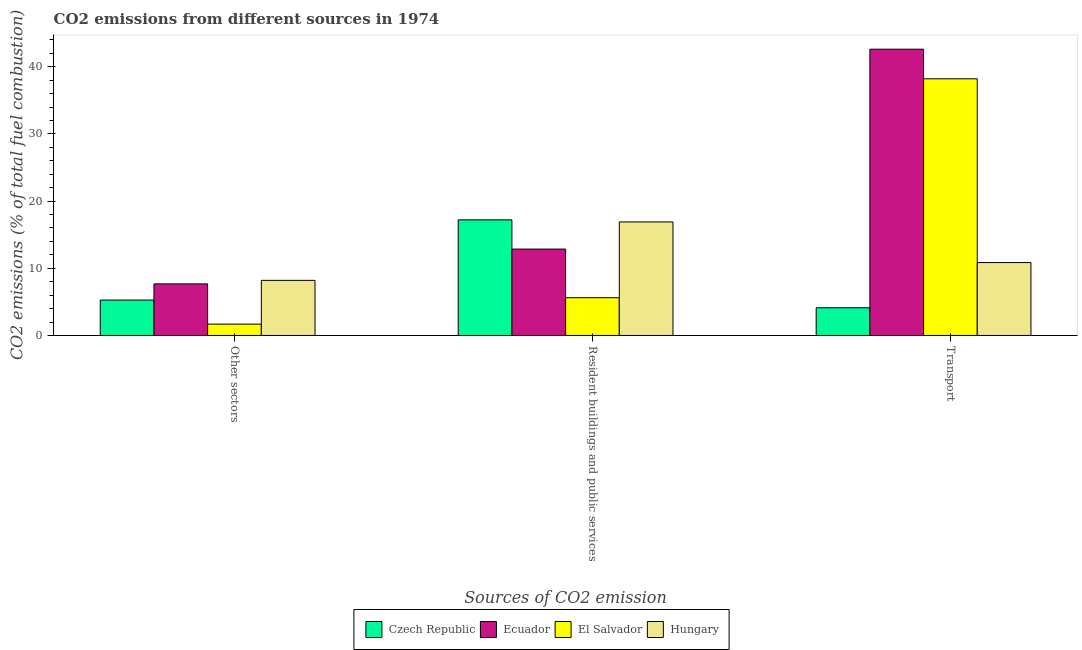Are the number of bars per tick equal to the number of legend labels?
Give a very brief answer. Yes. What is the label of the 2nd group of bars from the left?
Offer a very short reply. Resident buildings and public services. What is the percentage of co2 emissions from resident buildings and public services in Ecuador?
Provide a succinct answer. 12.86. Across all countries, what is the maximum percentage of co2 emissions from other sectors?
Offer a very short reply. 8.2. Across all countries, what is the minimum percentage of co2 emissions from other sectors?
Your response must be concise. 1.69. In which country was the percentage of co2 emissions from other sectors maximum?
Offer a very short reply. Hungary. In which country was the percentage of co2 emissions from transport minimum?
Ensure brevity in your answer.  Czech Republic. What is the total percentage of co2 emissions from other sectors in the graph?
Make the answer very short. 22.84. What is the difference between the percentage of co2 emissions from other sectors in Czech Republic and that in Ecuador?
Keep it short and to the point. -2.41. What is the difference between the percentage of co2 emissions from other sectors in Czech Republic and the percentage of co2 emissions from transport in El Salvador?
Make the answer very short. -32.93. What is the average percentage of co2 emissions from transport per country?
Offer a terse response. 23.95. What is the difference between the percentage of co2 emissions from resident buildings and public services and percentage of co2 emissions from transport in Hungary?
Your answer should be compact. 6.05. What is the ratio of the percentage of co2 emissions from resident buildings and public services in Czech Republic to that in Hungary?
Give a very brief answer. 1.02. Is the percentage of co2 emissions from transport in Ecuador less than that in Czech Republic?
Provide a succinct answer. No. Is the difference between the percentage of co2 emissions from resident buildings and public services in El Salvador and Hungary greater than the difference between the percentage of co2 emissions from transport in El Salvador and Hungary?
Offer a very short reply. No. What is the difference between the highest and the second highest percentage of co2 emissions from resident buildings and public services?
Provide a succinct answer. 0.31. What is the difference between the highest and the lowest percentage of co2 emissions from resident buildings and public services?
Ensure brevity in your answer.  11.59. What does the 3rd bar from the left in Other sectors represents?
Provide a succinct answer. El Salvador. What does the 1st bar from the right in Transport represents?
Offer a very short reply. Hungary. How many bars are there?
Keep it short and to the point. 12. Are all the bars in the graph horizontal?
Keep it short and to the point. No. What is the difference between two consecutive major ticks on the Y-axis?
Give a very brief answer. 10. Are the values on the major ticks of Y-axis written in scientific E-notation?
Your answer should be very brief. No. Does the graph contain any zero values?
Keep it short and to the point. No. Does the graph contain grids?
Give a very brief answer. No. How many legend labels are there?
Ensure brevity in your answer.  4. What is the title of the graph?
Offer a terse response. CO2 emissions from different sources in 1974. Does "Ireland" appear as one of the legend labels in the graph?
Make the answer very short. No. What is the label or title of the X-axis?
Give a very brief answer. Sources of CO2 emission. What is the label or title of the Y-axis?
Offer a very short reply. CO2 emissions (% of total fuel combustion). What is the CO2 emissions (% of total fuel combustion) in Czech Republic in Other sectors?
Ensure brevity in your answer.  5.27. What is the CO2 emissions (% of total fuel combustion) of Ecuador in Other sectors?
Make the answer very short. 7.68. What is the CO2 emissions (% of total fuel combustion) of El Salvador in Other sectors?
Your response must be concise. 1.69. What is the CO2 emissions (% of total fuel combustion) of Hungary in Other sectors?
Provide a succinct answer. 8.2. What is the CO2 emissions (% of total fuel combustion) in Czech Republic in Resident buildings and public services?
Offer a terse response. 17.21. What is the CO2 emissions (% of total fuel combustion) of Ecuador in Resident buildings and public services?
Your response must be concise. 12.86. What is the CO2 emissions (% of total fuel combustion) of El Salvador in Resident buildings and public services?
Offer a very short reply. 5.62. What is the CO2 emissions (% of total fuel combustion) in Hungary in Resident buildings and public services?
Your response must be concise. 16.9. What is the CO2 emissions (% of total fuel combustion) in Czech Republic in Transport?
Your answer should be very brief. 4.12. What is the CO2 emissions (% of total fuel combustion) of Ecuador in Transport?
Your answer should be compact. 42.61. What is the CO2 emissions (% of total fuel combustion) in El Salvador in Transport?
Keep it short and to the point. 38.2. What is the CO2 emissions (% of total fuel combustion) in Hungary in Transport?
Keep it short and to the point. 10.85. Across all Sources of CO2 emission, what is the maximum CO2 emissions (% of total fuel combustion) of Czech Republic?
Make the answer very short. 17.21. Across all Sources of CO2 emission, what is the maximum CO2 emissions (% of total fuel combustion) in Ecuador?
Give a very brief answer. 42.61. Across all Sources of CO2 emission, what is the maximum CO2 emissions (% of total fuel combustion) in El Salvador?
Offer a terse response. 38.2. Across all Sources of CO2 emission, what is the maximum CO2 emissions (% of total fuel combustion) in Hungary?
Keep it short and to the point. 16.9. Across all Sources of CO2 emission, what is the minimum CO2 emissions (% of total fuel combustion) in Czech Republic?
Give a very brief answer. 4.12. Across all Sources of CO2 emission, what is the minimum CO2 emissions (% of total fuel combustion) in Ecuador?
Keep it short and to the point. 7.68. Across all Sources of CO2 emission, what is the minimum CO2 emissions (% of total fuel combustion) of El Salvador?
Make the answer very short. 1.69. Across all Sources of CO2 emission, what is the minimum CO2 emissions (% of total fuel combustion) of Hungary?
Keep it short and to the point. 8.2. What is the total CO2 emissions (% of total fuel combustion) of Czech Republic in the graph?
Give a very brief answer. 26.6. What is the total CO2 emissions (% of total fuel combustion) of Ecuador in the graph?
Your response must be concise. 63.15. What is the total CO2 emissions (% of total fuel combustion) of El Salvador in the graph?
Your response must be concise. 45.51. What is the total CO2 emissions (% of total fuel combustion) of Hungary in the graph?
Your answer should be compact. 35.95. What is the difference between the CO2 emissions (% of total fuel combustion) of Czech Republic in Other sectors and that in Resident buildings and public services?
Ensure brevity in your answer.  -11.94. What is the difference between the CO2 emissions (% of total fuel combustion) of Ecuador in Other sectors and that in Resident buildings and public services?
Provide a succinct answer. -5.18. What is the difference between the CO2 emissions (% of total fuel combustion) in El Salvador in Other sectors and that in Resident buildings and public services?
Your answer should be compact. -3.93. What is the difference between the CO2 emissions (% of total fuel combustion) in Hungary in Other sectors and that in Resident buildings and public services?
Provide a short and direct response. -8.7. What is the difference between the CO2 emissions (% of total fuel combustion) in Czech Republic in Other sectors and that in Transport?
Your response must be concise. 1.15. What is the difference between the CO2 emissions (% of total fuel combustion) of Ecuador in Other sectors and that in Transport?
Your answer should be very brief. -34.93. What is the difference between the CO2 emissions (% of total fuel combustion) of El Salvador in Other sectors and that in Transport?
Provide a short and direct response. -36.52. What is the difference between the CO2 emissions (% of total fuel combustion) of Hungary in Other sectors and that in Transport?
Ensure brevity in your answer.  -2.65. What is the difference between the CO2 emissions (% of total fuel combustion) of Czech Republic in Resident buildings and public services and that in Transport?
Make the answer very short. 13.09. What is the difference between the CO2 emissions (% of total fuel combustion) in Ecuador in Resident buildings and public services and that in Transport?
Your answer should be very brief. -29.75. What is the difference between the CO2 emissions (% of total fuel combustion) in El Salvador in Resident buildings and public services and that in Transport?
Keep it short and to the point. -32.58. What is the difference between the CO2 emissions (% of total fuel combustion) in Hungary in Resident buildings and public services and that in Transport?
Your response must be concise. 6.05. What is the difference between the CO2 emissions (% of total fuel combustion) of Czech Republic in Other sectors and the CO2 emissions (% of total fuel combustion) of Ecuador in Resident buildings and public services?
Keep it short and to the point. -7.59. What is the difference between the CO2 emissions (% of total fuel combustion) of Czech Republic in Other sectors and the CO2 emissions (% of total fuel combustion) of El Salvador in Resident buildings and public services?
Give a very brief answer. -0.35. What is the difference between the CO2 emissions (% of total fuel combustion) in Czech Republic in Other sectors and the CO2 emissions (% of total fuel combustion) in Hungary in Resident buildings and public services?
Keep it short and to the point. -11.63. What is the difference between the CO2 emissions (% of total fuel combustion) of Ecuador in Other sectors and the CO2 emissions (% of total fuel combustion) of El Salvador in Resident buildings and public services?
Offer a terse response. 2.06. What is the difference between the CO2 emissions (% of total fuel combustion) in Ecuador in Other sectors and the CO2 emissions (% of total fuel combustion) in Hungary in Resident buildings and public services?
Your answer should be very brief. -9.22. What is the difference between the CO2 emissions (% of total fuel combustion) of El Salvador in Other sectors and the CO2 emissions (% of total fuel combustion) of Hungary in Resident buildings and public services?
Keep it short and to the point. -15.21. What is the difference between the CO2 emissions (% of total fuel combustion) of Czech Republic in Other sectors and the CO2 emissions (% of total fuel combustion) of Ecuador in Transport?
Provide a short and direct response. -37.34. What is the difference between the CO2 emissions (% of total fuel combustion) in Czech Republic in Other sectors and the CO2 emissions (% of total fuel combustion) in El Salvador in Transport?
Provide a short and direct response. -32.93. What is the difference between the CO2 emissions (% of total fuel combustion) of Czech Republic in Other sectors and the CO2 emissions (% of total fuel combustion) of Hungary in Transport?
Ensure brevity in your answer.  -5.58. What is the difference between the CO2 emissions (% of total fuel combustion) of Ecuador in Other sectors and the CO2 emissions (% of total fuel combustion) of El Salvador in Transport?
Make the answer very short. -30.52. What is the difference between the CO2 emissions (% of total fuel combustion) of Ecuador in Other sectors and the CO2 emissions (% of total fuel combustion) of Hungary in Transport?
Your answer should be compact. -3.17. What is the difference between the CO2 emissions (% of total fuel combustion) of El Salvador in Other sectors and the CO2 emissions (% of total fuel combustion) of Hungary in Transport?
Offer a very short reply. -9.16. What is the difference between the CO2 emissions (% of total fuel combustion) in Czech Republic in Resident buildings and public services and the CO2 emissions (% of total fuel combustion) in Ecuador in Transport?
Keep it short and to the point. -25.4. What is the difference between the CO2 emissions (% of total fuel combustion) in Czech Republic in Resident buildings and public services and the CO2 emissions (% of total fuel combustion) in El Salvador in Transport?
Provide a short and direct response. -20.99. What is the difference between the CO2 emissions (% of total fuel combustion) of Czech Republic in Resident buildings and public services and the CO2 emissions (% of total fuel combustion) of Hungary in Transport?
Keep it short and to the point. 6.36. What is the difference between the CO2 emissions (% of total fuel combustion) of Ecuador in Resident buildings and public services and the CO2 emissions (% of total fuel combustion) of El Salvador in Transport?
Your answer should be very brief. -25.34. What is the difference between the CO2 emissions (% of total fuel combustion) of Ecuador in Resident buildings and public services and the CO2 emissions (% of total fuel combustion) of Hungary in Transport?
Keep it short and to the point. 2.01. What is the difference between the CO2 emissions (% of total fuel combustion) of El Salvador in Resident buildings and public services and the CO2 emissions (% of total fuel combustion) of Hungary in Transport?
Ensure brevity in your answer.  -5.23. What is the average CO2 emissions (% of total fuel combustion) in Czech Republic per Sources of CO2 emission?
Your answer should be compact. 8.87. What is the average CO2 emissions (% of total fuel combustion) in Ecuador per Sources of CO2 emission?
Provide a succinct answer. 21.05. What is the average CO2 emissions (% of total fuel combustion) in El Salvador per Sources of CO2 emission?
Offer a terse response. 15.17. What is the average CO2 emissions (% of total fuel combustion) in Hungary per Sources of CO2 emission?
Offer a terse response. 11.98. What is the difference between the CO2 emissions (% of total fuel combustion) of Czech Republic and CO2 emissions (% of total fuel combustion) of Ecuador in Other sectors?
Your response must be concise. -2.41. What is the difference between the CO2 emissions (% of total fuel combustion) in Czech Republic and CO2 emissions (% of total fuel combustion) in El Salvador in Other sectors?
Provide a short and direct response. 3.59. What is the difference between the CO2 emissions (% of total fuel combustion) in Czech Republic and CO2 emissions (% of total fuel combustion) in Hungary in Other sectors?
Provide a short and direct response. -2.93. What is the difference between the CO2 emissions (% of total fuel combustion) in Ecuador and CO2 emissions (% of total fuel combustion) in El Salvador in Other sectors?
Your answer should be very brief. 5.99. What is the difference between the CO2 emissions (% of total fuel combustion) of Ecuador and CO2 emissions (% of total fuel combustion) of Hungary in Other sectors?
Provide a short and direct response. -0.52. What is the difference between the CO2 emissions (% of total fuel combustion) of El Salvador and CO2 emissions (% of total fuel combustion) of Hungary in Other sectors?
Ensure brevity in your answer.  -6.52. What is the difference between the CO2 emissions (% of total fuel combustion) in Czech Republic and CO2 emissions (% of total fuel combustion) in Ecuador in Resident buildings and public services?
Your answer should be compact. 4.35. What is the difference between the CO2 emissions (% of total fuel combustion) of Czech Republic and CO2 emissions (% of total fuel combustion) of El Salvador in Resident buildings and public services?
Offer a very short reply. 11.59. What is the difference between the CO2 emissions (% of total fuel combustion) of Czech Republic and CO2 emissions (% of total fuel combustion) of Hungary in Resident buildings and public services?
Your response must be concise. 0.31. What is the difference between the CO2 emissions (% of total fuel combustion) in Ecuador and CO2 emissions (% of total fuel combustion) in El Salvador in Resident buildings and public services?
Make the answer very short. 7.24. What is the difference between the CO2 emissions (% of total fuel combustion) of Ecuador and CO2 emissions (% of total fuel combustion) of Hungary in Resident buildings and public services?
Offer a very short reply. -4.04. What is the difference between the CO2 emissions (% of total fuel combustion) of El Salvador and CO2 emissions (% of total fuel combustion) of Hungary in Resident buildings and public services?
Make the answer very short. -11.28. What is the difference between the CO2 emissions (% of total fuel combustion) of Czech Republic and CO2 emissions (% of total fuel combustion) of Ecuador in Transport?
Give a very brief answer. -38.49. What is the difference between the CO2 emissions (% of total fuel combustion) of Czech Republic and CO2 emissions (% of total fuel combustion) of El Salvador in Transport?
Offer a terse response. -34.08. What is the difference between the CO2 emissions (% of total fuel combustion) in Czech Republic and CO2 emissions (% of total fuel combustion) in Hungary in Transport?
Offer a terse response. -6.73. What is the difference between the CO2 emissions (% of total fuel combustion) in Ecuador and CO2 emissions (% of total fuel combustion) in El Salvador in Transport?
Offer a very short reply. 4.41. What is the difference between the CO2 emissions (% of total fuel combustion) in Ecuador and CO2 emissions (% of total fuel combustion) in Hungary in Transport?
Offer a terse response. 31.76. What is the difference between the CO2 emissions (% of total fuel combustion) of El Salvador and CO2 emissions (% of total fuel combustion) of Hungary in Transport?
Offer a terse response. 27.35. What is the ratio of the CO2 emissions (% of total fuel combustion) of Czech Republic in Other sectors to that in Resident buildings and public services?
Keep it short and to the point. 0.31. What is the ratio of the CO2 emissions (% of total fuel combustion) in Ecuador in Other sectors to that in Resident buildings and public services?
Give a very brief answer. 0.6. What is the ratio of the CO2 emissions (% of total fuel combustion) of Hungary in Other sectors to that in Resident buildings and public services?
Your response must be concise. 0.49. What is the ratio of the CO2 emissions (% of total fuel combustion) in Czech Republic in Other sectors to that in Transport?
Provide a short and direct response. 1.28. What is the ratio of the CO2 emissions (% of total fuel combustion) of Ecuador in Other sectors to that in Transport?
Keep it short and to the point. 0.18. What is the ratio of the CO2 emissions (% of total fuel combustion) in El Salvador in Other sectors to that in Transport?
Offer a very short reply. 0.04. What is the ratio of the CO2 emissions (% of total fuel combustion) of Hungary in Other sectors to that in Transport?
Your answer should be compact. 0.76. What is the ratio of the CO2 emissions (% of total fuel combustion) of Czech Republic in Resident buildings and public services to that in Transport?
Make the answer very short. 4.17. What is the ratio of the CO2 emissions (% of total fuel combustion) of Ecuador in Resident buildings and public services to that in Transport?
Your answer should be very brief. 0.3. What is the ratio of the CO2 emissions (% of total fuel combustion) of El Salvador in Resident buildings and public services to that in Transport?
Your answer should be very brief. 0.15. What is the ratio of the CO2 emissions (% of total fuel combustion) in Hungary in Resident buildings and public services to that in Transport?
Your answer should be compact. 1.56. What is the difference between the highest and the second highest CO2 emissions (% of total fuel combustion) of Czech Republic?
Your answer should be compact. 11.94. What is the difference between the highest and the second highest CO2 emissions (% of total fuel combustion) of Ecuador?
Provide a succinct answer. 29.75. What is the difference between the highest and the second highest CO2 emissions (% of total fuel combustion) of El Salvador?
Provide a short and direct response. 32.58. What is the difference between the highest and the second highest CO2 emissions (% of total fuel combustion) in Hungary?
Provide a succinct answer. 6.05. What is the difference between the highest and the lowest CO2 emissions (% of total fuel combustion) of Czech Republic?
Your answer should be compact. 13.09. What is the difference between the highest and the lowest CO2 emissions (% of total fuel combustion) in Ecuador?
Make the answer very short. 34.93. What is the difference between the highest and the lowest CO2 emissions (% of total fuel combustion) of El Salvador?
Provide a succinct answer. 36.52. What is the difference between the highest and the lowest CO2 emissions (% of total fuel combustion) in Hungary?
Ensure brevity in your answer.  8.7. 